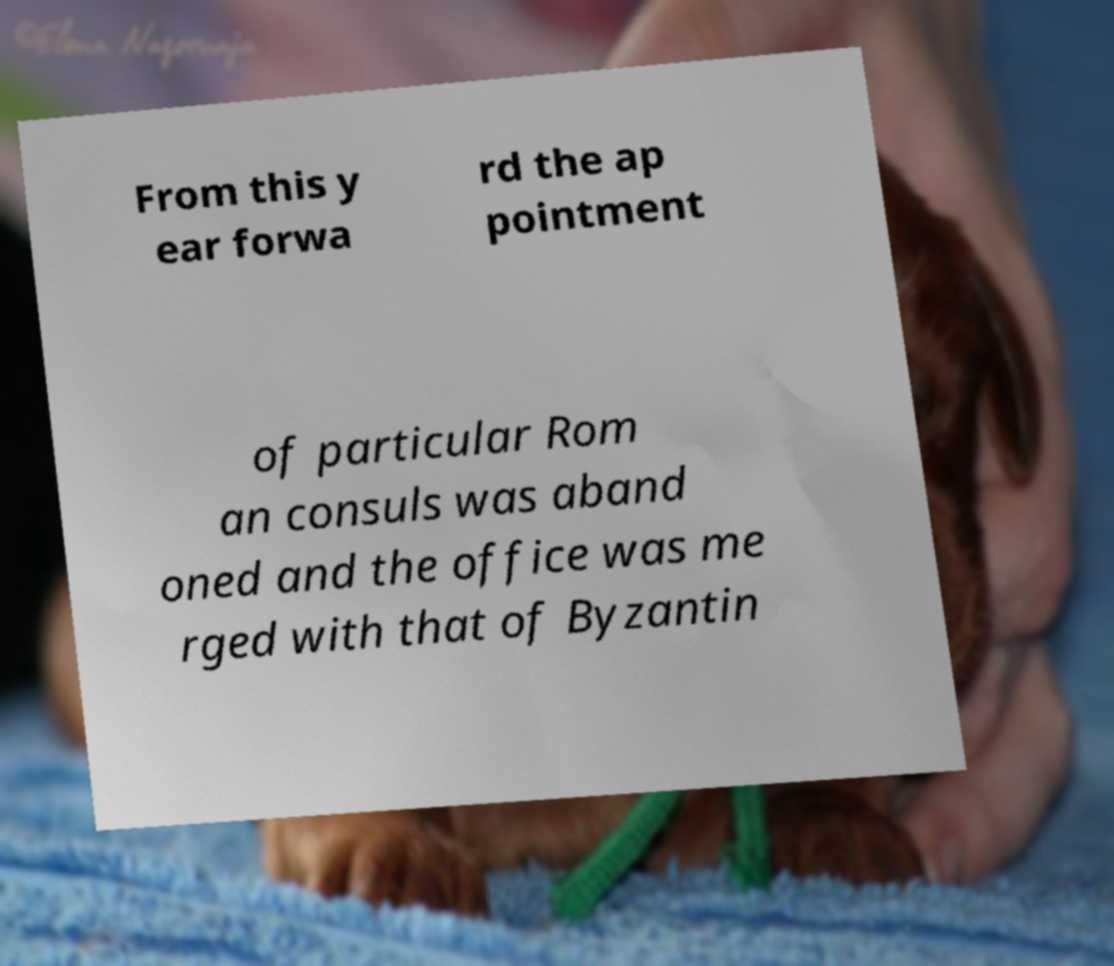Can you read and provide the text displayed in the image?This photo seems to have some interesting text. Can you extract and type it out for me? From this y ear forwa rd the ap pointment of particular Rom an consuls was aband oned and the office was me rged with that of Byzantin 